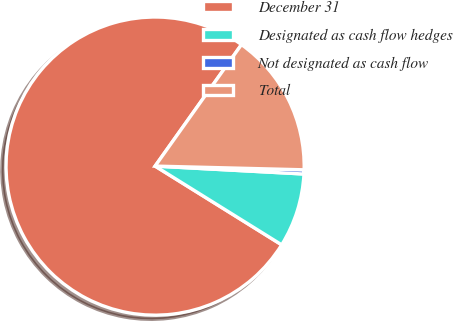Convert chart to OTSL. <chart><loc_0><loc_0><loc_500><loc_500><pie_chart><fcel>December 31<fcel>Designated as cash flow hedges<fcel>Not designated as cash flow<fcel>Total<nl><fcel>75.98%<fcel>8.01%<fcel>0.45%<fcel>15.56%<nl></chart> 